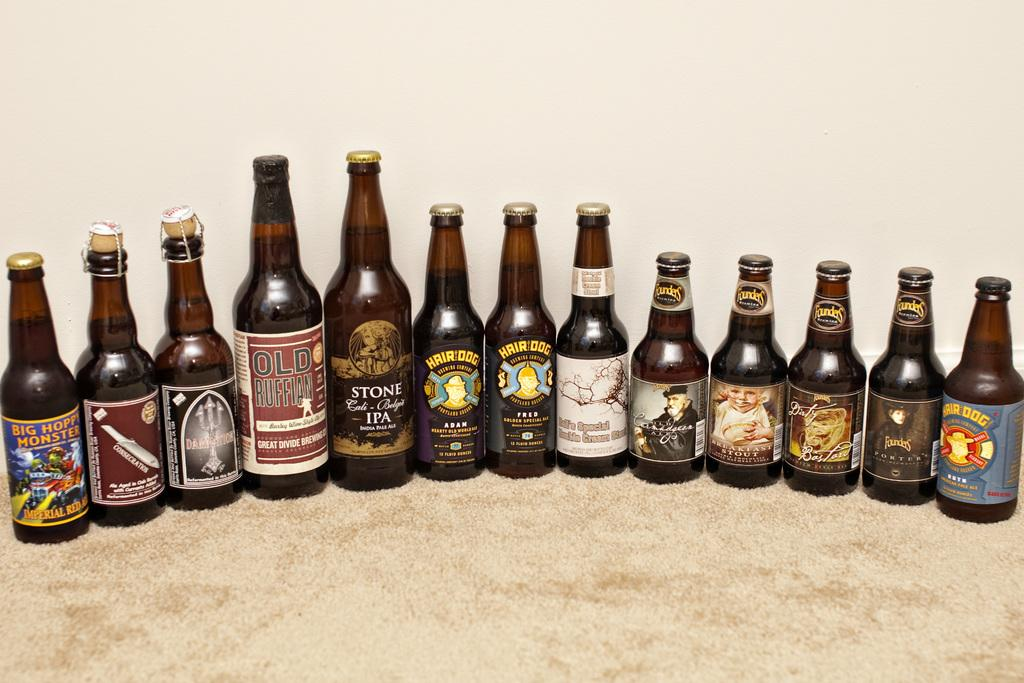<image>
Offer a succinct explanation of the picture presented. A bottle on the far left has a label that says, Big Hoppy Monster. 